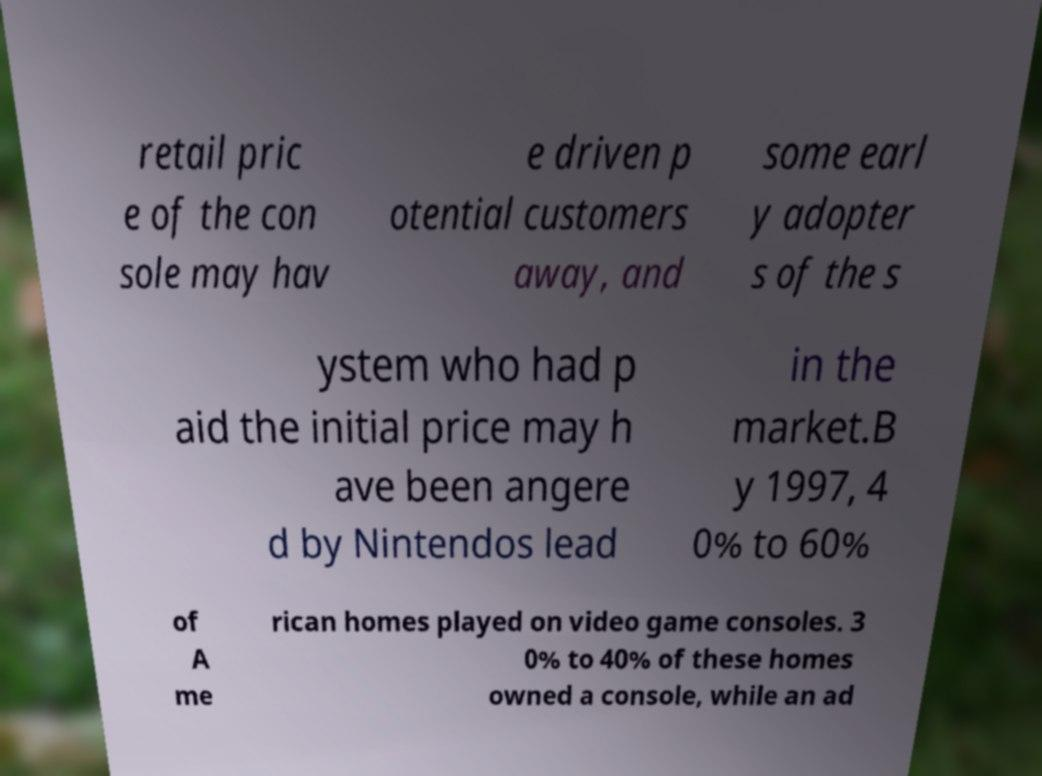What messages or text are displayed in this image? I need them in a readable, typed format. retail pric e of the con sole may hav e driven p otential customers away, and some earl y adopter s of the s ystem who had p aid the initial price may h ave been angere d by Nintendos lead in the market.B y 1997, 4 0% to 60% of A me rican homes played on video game consoles. 3 0% to 40% of these homes owned a console, while an ad 